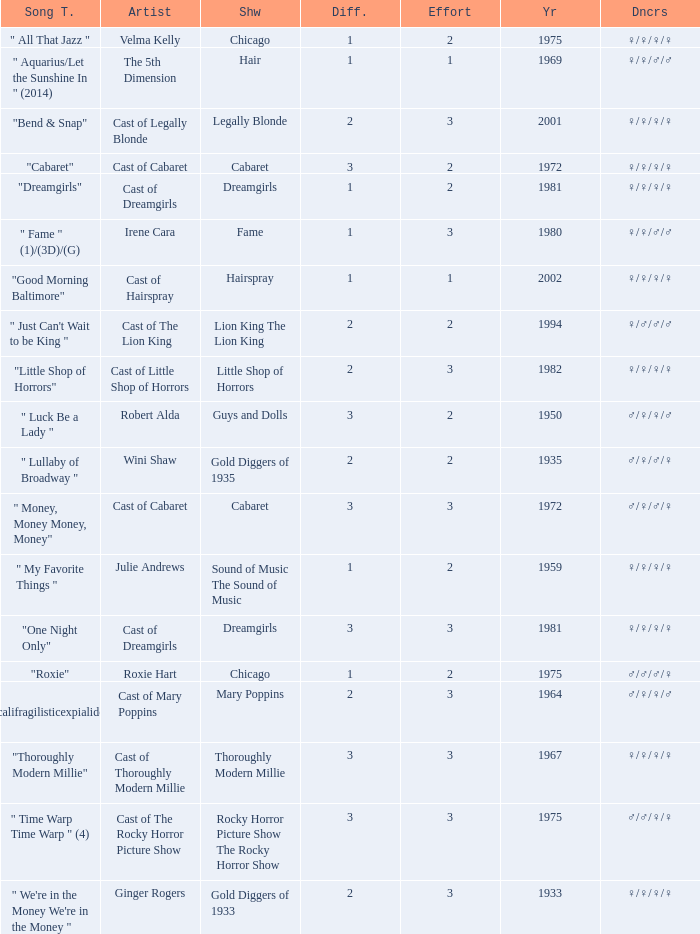What show featured the song "little shop of horrors"? Little Shop of Horrors. Would you mind parsing the complete table? {'header': ['Song T.', 'Artist', 'Shw', 'Diff.', 'Effort', 'Yr', 'Dncrs'], 'rows': [['" All That Jazz "', 'Velma Kelly', 'Chicago', '1', '2', '1975', '♀/♀/♀/♀'], ['" Aquarius/Let the Sunshine In " (2014)', 'The 5th Dimension', 'Hair', '1', '1', '1969', '♀/♀/♂/♂'], ['"Bend & Snap"', 'Cast of Legally Blonde', 'Legally Blonde', '2', '3', '2001', '♀/♀/♀/♀'], ['"Cabaret"', 'Cast of Cabaret', 'Cabaret', '3', '2', '1972', '♀/♀/♀/♀'], ['"Dreamgirls"', 'Cast of Dreamgirls', 'Dreamgirls', '1', '2', '1981', '♀/♀/♀/♀'], ['" Fame " (1)/(3D)/(G)', 'Irene Cara', 'Fame', '1', '3', '1980', '♀/♀/♂/♂'], ['"Good Morning Baltimore"', 'Cast of Hairspray', 'Hairspray', '1', '1', '2002', '♀/♀/♀/♀'], ['" Just Can\'t Wait to be King "', 'Cast of The Lion King', 'Lion King The Lion King', '2', '2', '1994', '♀/♂/♂/♂'], ['"Little Shop of Horrors"', 'Cast of Little Shop of Horrors', 'Little Shop of Horrors', '2', '3', '1982', '♀/♀/♀/♀'], ['" Luck Be a Lady "', 'Robert Alda', 'Guys and Dolls', '3', '2', '1950', '♂/♀/♀/♂'], ['" Lullaby of Broadway "', 'Wini Shaw', 'Gold Diggers of 1935', '2', '2', '1935', '♂/♀/♂/♀'], ['" Money, Money Money, Money"', 'Cast of Cabaret', 'Cabaret', '3', '3', '1972', '♂/♀/♂/♀'], ['" My Favorite Things "', 'Julie Andrews', 'Sound of Music The Sound of Music', '1', '2', '1959', '♀/♀/♀/♀'], ['"One Night Only"', 'Cast of Dreamgirls', 'Dreamgirls', '3', '3', '1981', '♀/♀/♀/♀'], ['"Roxie"', 'Roxie Hart', 'Chicago', '1', '2', '1975', '♂/♂/♂/♀'], ['" Supercalifragilisticexpialidocious " (DP)', 'Cast of Mary Poppins', 'Mary Poppins', '2', '3', '1964', '♂/♀/♀/♂'], ['"Thoroughly Modern Millie"', 'Cast of Thoroughly Modern Millie', 'Thoroughly Modern Millie', '3', '3', '1967', '♀/♀/♀/♀'], ['" Time Warp Time Warp " (4)', 'Cast of The Rocky Horror Picture Show', 'Rocky Horror Picture Show The Rocky Horror Show', '3', '3', '1975', '♂/♂/♀/♀'], ['" We\'re in the Money We\'re in the Money "', 'Ginger Rogers', 'Gold Diggers of 1933', '2', '3', '1933', '♀/♀/♀/♀']]} 